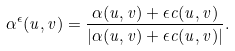<formula> <loc_0><loc_0><loc_500><loc_500>\alpha ^ { \epsilon } ( u , v ) = \frac { \alpha ( u , v ) + \epsilon c ( u , v ) } { | \alpha ( u , v ) + \epsilon c ( u , v ) | } .</formula> 